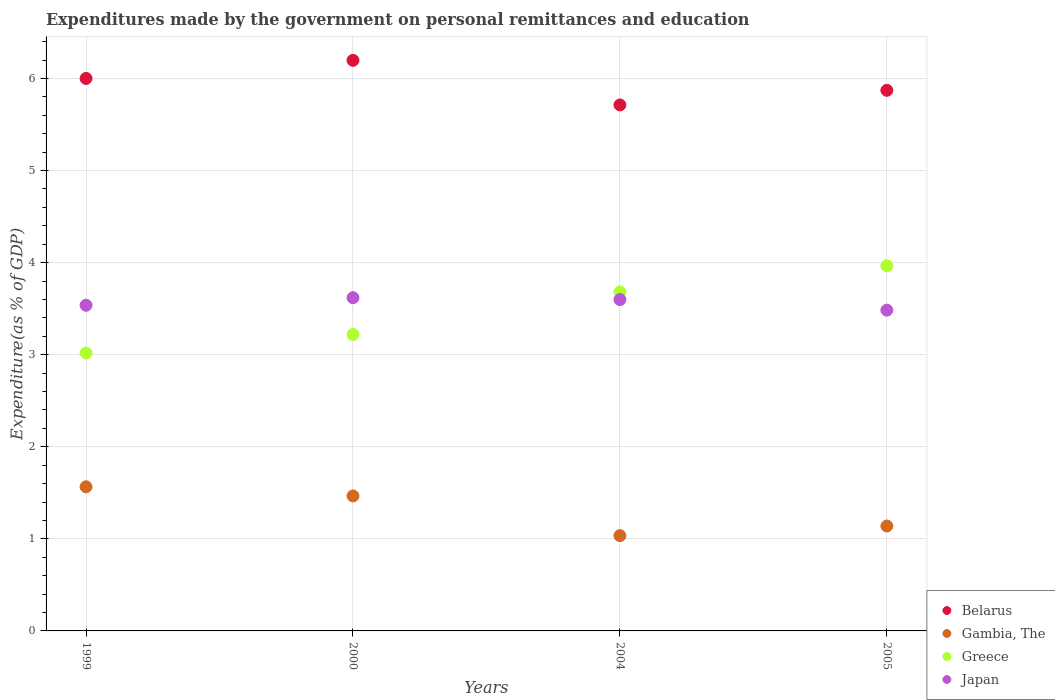How many different coloured dotlines are there?
Your answer should be very brief. 4. What is the expenditures made by the government on personal remittances and education in Greece in 2000?
Ensure brevity in your answer.  3.22. Across all years, what is the maximum expenditures made by the government on personal remittances and education in Japan?
Provide a short and direct response. 3.62. Across all years, what is the minimum expenditures made by the government on personal remittances and education in Belarus?
Your response must be concise. 5.71. What is the total expenditures made by the government on personal remittances and education in Japan in the graph?
Keep it short and to the point. 14.24. What is the difference between the expenditures made by the government on personal remittances and education in Greece in 2004 and that in 2005?
Your answer should be very brief. -0.29. What is the difference between the expenditures made by the government on personal remittances and education in Japan in 2004 and the expenditures made by the government on personal remittances and education in Belarus in 2000?
Your answer should be compact. -2.6. What is the average expenditures made by the government on personal remittances and education in Belarus per year?
Your response must be concise. 5.94. In the year 2000, what is the difference between the expenditures made by the government on personal remittances and education in Japan and expenditures made by the government on personal remittances and education in Greece?
Your response must be concise. 0.4. In how many years, is the expenditures made by the government on personal remittances and education in Belarus greater than 1.4 %?
Make the answer very short. 4. What is the ratio of the expenditures made by the government on personal remittances and education in Gambia, The in 2004 to that in 2005?
Offer a very short reply. 0.91. Is the expenditures made by the government on personal remittances and education in Gambia, The in 1999 less than that in 2005?
Offer a very short reply. No. Is the difference between the expenditures made by the government on personal remittances and education in Japan in 2000 and 2004 greater than the difference between the expenditures made by the government on personal remittances and education in Greece in 2000 and 2004?
Offer a very short reply. Yes. What is the difference between the highest and the second highest expenditures made by the government on personal remittances and education in Gambia, The?
Provide a succinct answer. 0.1. What is the difference between the highest and the lowest expenditures made by the government on personal remittances and education in Gambia, The?
Your answer should be very brief. 0.53. In how many years, is the expenditures made by the government on personal remittances and education in Greece greater than the average expenditures made by the government on personal remittances and education in Greece taken over all years?
Make the answer very short. 2. Is it the case that in every year, the sum of the expenditures made by the government on personal remittances and education in Gambia, The and expenditures made by the government on personal remittances and education in Japan  is greater than the sum of expenditures made by the government on personal remittances and education in Belarus and expenditures made by the government on personal remittances and education in Greece?
Your answer should be very brief. No. Is the expenditures made by the government on personal remittances and education in Greece strictly greater than the expenditures made by the government on personal remittances and education in Japan over the years?
Your answer should be very brief. No. How many years are there in the graph?
Your response must be concise. 4. What is the difference between two consecutive major ticks on the Y-axis?
Provide a short and direct response. 1. Are the values on the major ticks of Y-axis written in scientific E-notation?
Your answer should be compact. No. Does the graph contain any zero values?
Offer a terse response. No. Does the graph contain grids?
Provide a succinct answer. Yes. Where does the legend appear in the graph?
Provide a short and direct response. Bottom right. How are the legend labels stacked?
Provide a succinct answer. Vertical. What is the title of the graph?
Give a very brief answer. Expenditures made by the government on personal remittances and education. What is the label or title of the X-axis?
Ensure brevity in your answer.  Years. What is the label or title of the Y-axis?
Your response must be concise. Expenditure(as % of GDP). What is the Expenditure(as % of GDP) of Belarus in 1999?
Keep it short and to the point. 6. What is the Expenditure(as % of GDP) in Gambia, The in 1999?
Offer a very short reply. 1.57. What is the Expenditure(as % of GDP) of Greece in 1999?
Offer a terse response. 3.02. What is the Expenditure(as % of GDP) of Japan in 1999?
Your answer should be very brief. 3.54. What is the Expenditure(as % of GDP) of Belarus in 2000?
Your answer should be very brief. 6.2. What is the Expenditure(as % of GDP) in Gambia, The in 2000?
Offer a terse response. 1.47. What is the Expenditure(as % of GDP) of Greece in 2000?
Give a very brief answer. 3.22. What is the Expenditure(as % of GDP) of Japan in 2000?
Keep it short and to the point. 3.62. What is the Expenditure(as % of GDP) in Belarus in 2004?
Provide a short and direct response. 5.71. What is the Expenditure(as % of GDP) in Gambia, The in 2004?
Your response must be concise. 1.03. What is the Expenditure(as % of GDP) in Greece in 2004?
Provide a succinct answer. 3.68. What is the Expenditure(as % of GDP) in Japan in 2004?
Your answer should be very brief. 3.6. What is the Expenditure(as % of GDP) of Belarus in 2005?
Provide a succinct answer. 5.87. What is the Expenditure(as % of GDP) in Gambia, The in 2005?
Provide a succinct answer. 1.14. What is the Expenditure(as % of GDP) of Greece in 2005?
Your answer should be very brief. 3.97. What is the Expenditure(as % of GDP) of Japan in 2005?
Ensure brevity in your answer.  3.48. Across all years, what is the maximum Expenditure(as % of GDP) of Belarus?
Offer a very short reply. 6.2. Across all years, what is the maximum Expenditure(as % of GDP) of Gambia, The?
Provide a short and direct response. 1.57. Across all years, what is the maximum Expenditure(as % of GDP) in Greece?
Offer a very short reply. 3.97. Across all years, what is the maximum Expenditure(as % of GDP) of Japan?
Offer a terse response. 3.62. Across all years, what is the minimum Expenditure(as % of GDP) of Belarus?
Keep it short and to the point. 5.71. Across all years, what is the minimum Expenditure(as % of GDP) in Gambia, The?
Your response must be concise. 1.03. Across all years, what is the minimum Expenditure(as % of GDP) in Greece?
Your response must be concise. 3.02. Across all years, what is the minimum Expenditure(as % of GDP) in Japan?
Give a very brief answer. 3.48. What is the total Expenditure(as % of GDP) in Belarus in the graph?
Your response must be concise. 23.78. What is the total Expenditure(as % of GDP) of Gambia, The in the graph?
Offer a terse response. 5.2. What is the total Expenditure(as % of GDP) in Greece in the graph?
Ensure brevity in your answer.  13.88. What is the total Expenditure(as % of GDP) of Japan in the graph?
Make the answer very short. 14.24. What is the difference between the Expenditure(as % of GDP) in Belarus in 1999 and that in 2000?
Offer a terse response. -0.2. What is the difference between the Expenditure(as % of GDP) of Gambia, The in 1999 and that in 2000?
Your answer should be very brief. 0.1. What is the difference between the Expenditure(as % of GDP) in Greece in 1999 and that in 2000?
Make the answer very short. -0.2. What is the difference between the Expenditure(as % of GDP) in Japan in 1999 and that in 2000?
Ensure brevity in your answer.  -0.08. What is the difference between the Expenditure(as % of GDP) in Belarus in 1999 and that in 2004?
Keep it short and to the point. 0.29. What is the difference between the Expenditure(as % of GDP) in Gambia, The in 1999 and that in 2004?
Provide a short and direct response. 0.53. What is the difference between the Expenditure(as % of GDP) of Greece in 1999 and that in 2004?
Make the answer very short. -0.66. What is the difference between the Expenditure(as % of GDP) in Japan in 1999 and that in 2004?
Your answer should be compact. -0.06. What is the difference between the Expenditure(as % of GDP) of Belarus in 1999 and that in 2005?
Your answer should be very brief. 0.13. What is the difference between the Expenditure(as % of GDP) of Gambia, The in 1999 and that in 2005?
Give a very brief answer. 0.43. What is the difference between the Expenditure(as % of GDP) in Greece in 1999 and that in 2005?
Make the answer very short. -0.95. What is the difference between the Expenditure(as % of GDP) in Japan in 1999 and that in 2005?
Make the answer very short. 0.05. What is the difference between the Expenditure(as % of GDP) of Belarus in 2000 and that in 2004?
Offer a terse response. 0.48. What is the difference between the Expenditure(as % of GDP) in Gambia, The in 2000 and that in 2004?
Keep it short and to the point. 0.43. What is the difference between the Expenditure(as % of GDP) of Greece in 2000 and that in 2004?
Your response must be concise. -0.46. What is the difference between the Expenditure(as % of GDP) in Japan in 2000 and that in 2004?
Provide a short and direct response. 0.02. What is the difference between the Expenditure(as % of GDP) in Belarus in 2000 and that in 2005?
Your response must be concise. 0.33. What is the difference between the Expenditure(as % of GDP) of Gambia, The in 2000 and that in 2005?
Provide a short and direct response. 0.33. What is the difference between the Expenditure(as % of GDP) of Greece in 2000 and that in 2005?
Your answer should be compact. -0.75. What is the difference between the Expenditure(as % of GDP) of Japan in 2000 and that in 2005?
Make the answer very short. 0.14. What is the difference between the Expenditure(as % of GDP) in Belarus in 2004 and that in 2005?
Offer a terse response. -0.16. What is the difference between the Expenditure(as % of GDP) of Gambia, The in 2004 and that in 2005?
Your answer should be very brief. -0.1. What is the difference between the Expenditure(as % of GDP) in Greece in 2004 and that in 2005?
Give a very brief answer. -0.29. What is the difference between the Expenditure(as % of GDP) in Japan in 2004 and that in 2005?
Keep it short and to the point. 0.11. What is the difference between the Expenditure(as % of GDP) of Belarus in 1999 and the Expenditure(as % of GDP) of Gambia, The in 2000?
Provide a succinct answer. 4.53. What is the difference between the Expenditure(as % of GDP) of Belarus in 1999 and the Expenditure(as % of GDP) of Greece in 2000?
Your response must be concise. 2.78. What is the difference between the Expenditure(as % of GDP) of Belarus in 1999 and the Expenditure(as % of GDP) of Japan in 2000?
Provide a short and direct response. 2.38. What is the difference between the Expenditure(as % of GDP) of Gambia, The in 1999 and the Expenditure(as % of GDP) of Greece in 2000?
Ensure brevity in your answer.  -1.65. What is the difference between the Expenditure(as % of GDP) in Gambia, The in 1999 and the Expenditure(as % of GDP) in Japan in 2000?
Make the answer very short. -2.05. What is the difference between the Expenditure(as % of GDP) in Greece in 1999 and the Expenditure(as % of GDP) in Japan in 2000?
Your response must be concise. -0.6. What is the difference between the Expenditure(as % of GDP) of Belarus in 1999 and the Expenditure(as % of GDP) of Gambia, The in 2004?
Ensure brevity in your answer.  4.97. What is the difference between the Expenditure(as % of GDP) in Belarus in 1999 and the Expenditure(as % of GDP) in Greece in 2004?
Your answer should be very brief. 2.32. What is the difference between the Expenditure(as % of GDP) in Belarus in 1999 and the Expenditure(as % of GDP) in Japan in 2004?
Keep it short and to the point. 2.4. What is the difference between the Expenditure(as % of GDP) in Gambia, The in 1999 and the Expenditure(as % of GDP) in Greece in 2004?
Your response must be concise. -2.12. What is the difference between the Expenditure(as % of GDP) in Gambia, The in 1999 and the Expenditure(as % of GDP) in Japan in 2004?
Make the answer very short. -2.03. What is the difference between the Expenditure(as % of GDP) in Greece in 1999 and the Expenditure(as % of GDP) in Japan in 2004?
Your answer should be very brief. -0.58. What is the difference between the Expenditure(as % of GDP) in Belarus in 1999 and the Expenditure(as % of GDP) in Gambia, The in 2005?
Ensure brevity in your answer.  4.86. What is the difference between the Expenditure(as % of GDP) of Belarus in 1999 and the Expenditure(as % of GDP) of Greece in 2005?
Give a very brief answer. 2.03. What is the difference between the Expenditure(as % of GDP) in Belarus in 1999 and the Expenditure(as % of GDP) in Japan in 2005?
Provide a short and direct response. 2.52. What is the difference between the Expenditure(as % of GDP) of Gambia, The in 1999 and the Expenditure(as % of GDP) of Greece in 2005?
Provide a succinct answer. -2.4. What is the difference between the Expenditure(as % of GDP) of Gambia, The in 1999 and the Expenditure(as % of GDP) of Japan in 2005?
Your answer should be compact. -1.92. What is the difference between the Expenditure(as % of GDP) of Greece in 1999 and the Expenditure(as % of GDP) of Japan in 2005?
Your answer should be compact. -0.47. What is the difference between the Expenditure(as % of GDP) of Belarus in 2000 and the Expenditure(as % of GDP) of Gambia, The in 2004?
Your response must be concise. 5.16. What is the difference between the Expenditure(as % of GDP) in Belarus in 2000 and the Expenditure(as % of GDP) in Greece in 2004?
Give a very brief answer. 2.52. What is the difference between the Expenditure(as % of GDP) of Belarus in 2000 and the Expenditure(as % of GDP) of Japan in 2004?
Ensure brevity in your answer.  2.6. What is the difference between the Expenditure(as % of GDP) of Gambia, The in 2000 and the Expenditure(as % of GDP) of Greece in 2004?
Give a very brief answer. -2.21. What is the difference between the Expenditure(as % of GDP) in Gambia, The in 2000 and the Expenditure(as % of GDP) in Japan in 2004?
Make the answer very short. -2.13. What is the difference between the Expenditure(as % of GDP) of Greece in 2000 and the Expenditure(as % of GDP) of Japan in 2004?
Offer a terse response. -0.38. What is the difference between the Expenditure(as % of GDP) of Belarus in 2000 and the Expenditure(as % of GDP) of Gambia, The in 2005?
Ensure brevity in your answer.  5.06. What is the difference between the Expenditure(as % of GDP) of Belarus in 2000 and the Expenditure(as % of GDP) of Greece in 2005?
Give a very brief answer. 2.23. What is the difference between the Expenditure(as % of GDP) of Belarus in 2000 and the Expenditure(as % of GDP) of Japan in 2005?
Offer a terse response. 2.71. What is the difference between the Expenditure(as % of GDP) of Gambia, The in 2000 and the Expenditure(as % of GDP) of Greece in 2005?
Make the answer very short. -2.5. What is the difference between the Expenditure(as % of GDP) of Gambia, The in 2000 and the Expenditure(as % of GDP) of Japan in 2005?
Make the answer very short. -2.02. What is the difference between the Expenditure(as % of GDP) of Greece in 2000 and the Expenditure(as % of GDP) of Japan in 2005?
Provide a short and direct response. -0.26. What is the difference between the Expenditure(as % of GDP) of Belarus in 2004 and the Expenditure(as % of GDP) of Gambia, The in 2005?
Give a very brief answer. 4.57. What is the difference between the Expenditure(as % of GDP) of Belarus in 2004 and the Expenditure(as % of GDP) of Greece in 2005?
Provide a short and direct response. 1.75. What is the difference between the Expenditure(as % of GDP) in Belarus in 2004 and the Expenditure(as % of GDP) in Japan in 2005?
Your answer should be compact. 2.23. What is the difference between the Expenditure(as % of GDP) of Gambia, The in 2004 and the Expenditure(as % of GDP) of Greece in 2005?
Your answer should be very brief. -2.93. What is the difference between the Expenditure(as % of GDP) of Gambia, The in 2004 and the Expenditure(as % of GDP) of Japan in 2005?
Make the answer very short. -2.45. What is the difference between the Expenditure(as % of GDP) in Greece in 2004 and the Expenditure(as % of GDP) in Japan in 2005?
Your response must be concise. 0.2. What is the average Expenditure(as % of GDP) of Belarus per year?
Your response must be concise. 5.95. What is the average Expenditure(as % of GDP) of Gambia, The per year?
Offer a very short reply. 1.3. What is the average Expenditure(as % of GDP) of Greece per year?
Ensure brevity in your answer.  3.47. What is the average Expenditure(as % of GDP) in Japan per year?
Make the answer very short. 3.56. In the year 1999, what is the difference between the Expenditure(as % of GDP) of Belarus and Expenditure(as % of GDP) of Gambia, The?
Make the answer very short. 4.43. In the year 1999, what is the difference between the Expenditure(as % of GDP) of Belarus and Expenditure(as % of GDP) of Greece?
Your answer should be very brief. 2.98. In the year 1999, what is the difference between the Expenditure(as % of GDP) of Belarus and Expenditure(as % of GDP) of Japan?
Offer a very short reply. 2.46. In the year 1999, what is the difference between the Expenditure(as % of GDP) of Gambia, The and Expenditure(as % of GDP) of Greece?
Your response must be concise. -1.45. In the year 1999, what is the difference between the Expenditure(as % of GDP) in Gambia, The and Expenditure(as % of GDP) in Japan?
Provide a short and direct response. -1.97. In the year 1999, what is the difference between the Expenditure(as % of GDP) in Greece and Expenditure(as % of GDP) in Japan?
Ensure brevity in your answer.  -0.52. In the year 2000, what is the difference between the Expenditure(as % of GDP) of Belarus and Expenditure(as % of GDP) of Gambia, The?
Offer a terse response. 4.73. In the year 2000, what is the difference between the Expenditure(as % of GDP) in Belarus and Expenditure(as % of GDP) in Greece?
Offer a terse response. 2.98. In the year 2000, what is the difference between the Expenditure(as % of GDP) in Belarus and Expenditure(as % of GDP) in Japan?
Your answer should be compact. 2.58. In the year 2000, what is the difference between the Expenditure(as % of GDP) in Gambia, The and Expenditure(as % of GDP) in Greece?
Keep it short and to the point. -1.75. In the year 2000, what is the difference between the Expenditure(as % of GDP) in Gambia, The and Expenditure(as % of GDP) in Japan?
Your answer should be very brief. -2.15. In the year 2000, what is the difference between the Expenditure(as % of GDP) in Greece and Expenditure(as % of GDP) in Japan?
Make the answer very short. -0.4. In the year 2004, what is the difference between the Expenditure(as % of GDP) of Belarus and Expenditure(as % of GDP) of Gambia, The?
Keep it short and to the point. 4.68. In the year 2004, what is the difference between the Expenditure(as % of GDP) of Belarus and Expenditure(as % of GDP) of Greece?
Offer a very short reply. 2.03. In the year 2004, what is the difference between the Expenditure(as % of GDP) in Belarus and Expenditure(as % of GDP) in Japan?
Make the answer very short. 2.11. In the year 2004, what is the difference between the Expenditure(as % of GDP) in Gambia, The and Expenditure(as % of GDP) in Greece?
Offer a terse response. -2.65. In the year 2004, what is the difference between the Expenditure(as % of GDP) of Gambia, The and Expenditure(as % of GDP) of Japan?
Offer a very short reply. -2.56. In the year 2004, what is the difference between the Expenditure(as % of GDP) in Greece and Expenditure(as % of GDP) in Japan?
Provide a short and direct response. 0.08. In the year 2005, what is the difference between the Expenditure(as % of GDP) in Belarus and Expenditure(as % of GDP) in Gambia, The?
Your response must be concise. 4.73. In the year 2005, what is the difference between the Expenditure(as % of GDP) of Belarus and Expenditure(as % of GDP) of Greece?
Provide a short and direct response. 1.91. In the year 2005, what is the difference between the Expenditure(as % of GDP) in Belarus and Expenditure(as % of GDP) in Japan?
Offer a very short reply. 2.39. In the year 2005, what is the difference between the Expenditure(as % of GDP) in Gambia, The and Expenditure(as % of GDP) in Greece?
Offer a very short reply. -2.83. In the year 2005, what is the difference between the Expenditure(as % of GDP) of Gambia, The and Expenditure(as % of GDP) of Japan?
Provide a short and direct response. -2.34. In the year 2005, what is the difference between the Expenditure(as % of GDP) of Greece and Expenditure(as % of GDP) of Japan?
Your answer should be very brief. 0.48. What is the ratio of the Expenditure(as % of GDP) of Belarus in 1999 to that in 2000?
Provide a succinct answer. 0.97. What is the ratio of the Expenditure(as % of GDP) in Gambia, The in 1999 to that in 2000?
Make the answer very short. 1.07. What is the ratio of the Expenditure(as % of GDP) of Greece in 1999 to that in 2000?
Keep it short and to the point. 0.94. What is the ratio of the Expenditure(as % of GDP) of Japan in 1999 to that in 2000?
Provide a succinct answer. 0.98. What is the ratio of the Expenditure(as % of GDP) in Belarus in 1999 to that in 2004?
Your answer should be compact. 1.05. What is the ratio of the Expenditure(as % of GDP) of Gambia, The in 1999 to that in 2004?
Make the answer very short. 1.51. What is the ratio of the Expenditure(as % of GDP) in Greece in 1999 to that in 2004?
Make the answer very short. 0.82. What is the ratio of the Expenditure(as % of GDP) in Japan in 1999 to that in 2004?
Provide a succinct answer. 0.98. What is the ratio of the Expenditure(as % of GDP) of Gambia, The in 1999 to that in 2005?
Offer a terse response. 1.37. What is the ratio of the Expenditure(as % of GDP) in Greece in 1999 to that in 2005?
Make the answer very short. 0.76. What is the ratio of the Expenditure(as % of GDP) in Japan in 1999 to that in 2005?
Make the answer very short. 1.02. What is the ratio of the Expenditure(as % of GDP) of Belarus in 2000 to that in 2004?
Make the answer very short. 1.08. What is the ratio of the Expenditure(as % of GDP) of Gambia, The in 2000 to that in 2004?
Offer a terse response. 1.42. What is the ratio of the Expenditure(as % of GDP) of Greece in 2000 to that in 2004?
Your answer should be very brief. 0.87. What is the ratio of the Expenditure(as % of GDP) of Japan in 2000 to that in 2004?
Your answer should be compact. 1.01. What is the ratio of the Expenditure(as % of GDP) in Belarus in 2000 to that in 2005?
Give a very brief answer. 1.06. What is the ratio of the Expenditure(as % of GDP) of Gambia, The in 2000 to that in 2005?
Make the answer very short. 1.29. What is the ratio of the Expenditure(as % of GDP) in Greece in 2000 to that in 2005?
Offer a very short reply. 0.81. What is the ratio of the Expenditure(as % of GDP) in Japan in 2000 to that in 2005?
Offer a very short reply. 1.04. What is the ratio of the Expenditure(as % of GDP) of Belarus in 2004 to that in 2005?
Offer a terse response. 0.97. What is the ratio of the Expenditure(as % of GDP) of Gambia, The in 2004 to that in 2005?
Offer a very short reply. 0.91. What is the ratio of the Expenditure(as % of GDP) of Greece in 2004 to that in 2005?
Ensure brevity in your answer.  0.93. What is the ratio of the Expenditure(as % of GDP) in Japan in 2004 to that in 2005?
Offer a very short reply. 1.03. What is the difference between the highest and the second highest Expenditure(as % of GDP) of Belarus?
Provide a short and direct response. 0.2. What is the difference between the highest and the second highest Expenditure(as % of GDP) of Gambia, The?
Make the answer very short. 0.1. What is the difference between the highest and the second highest Expenditure(as % of GDP) of Greece?
Provide a succinct answer. 0.29. What is the difference between the highest and the second highest Expenditure(as % of GDP) of Japan?
Your answer should be very brief. 0.02. What is the difference between the highest and the lowest Expenditure(as % of GDP) in Belarus?
Your response must be concise. 0.48. What is the difference between the highest and the lowest Expenditure(as % of GDP) of Gambia, The?
Your response must be concise. 0.53. What is the difference between the highest and the lowest Expenditure(as % of GDP) in Greece?
Make the answer very short. 0.95. What is the difference between the highest and the lowest Expenditure(as % of GDP) of Japan?
Your answer should be compact. 0.14. 